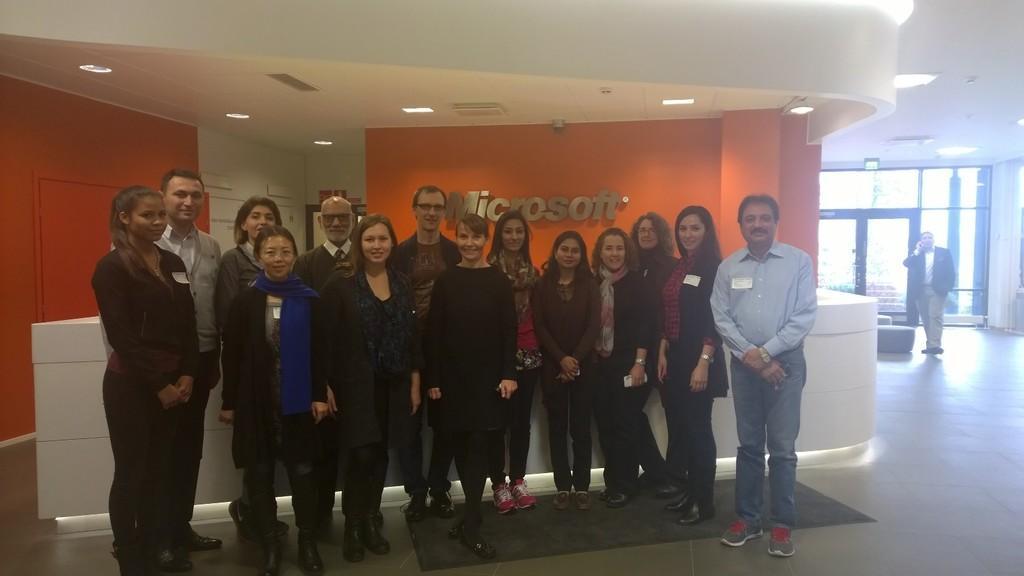Can you describe this image briefly? Group of people standing and we can see floor. Background we can see person,wall and lights. 